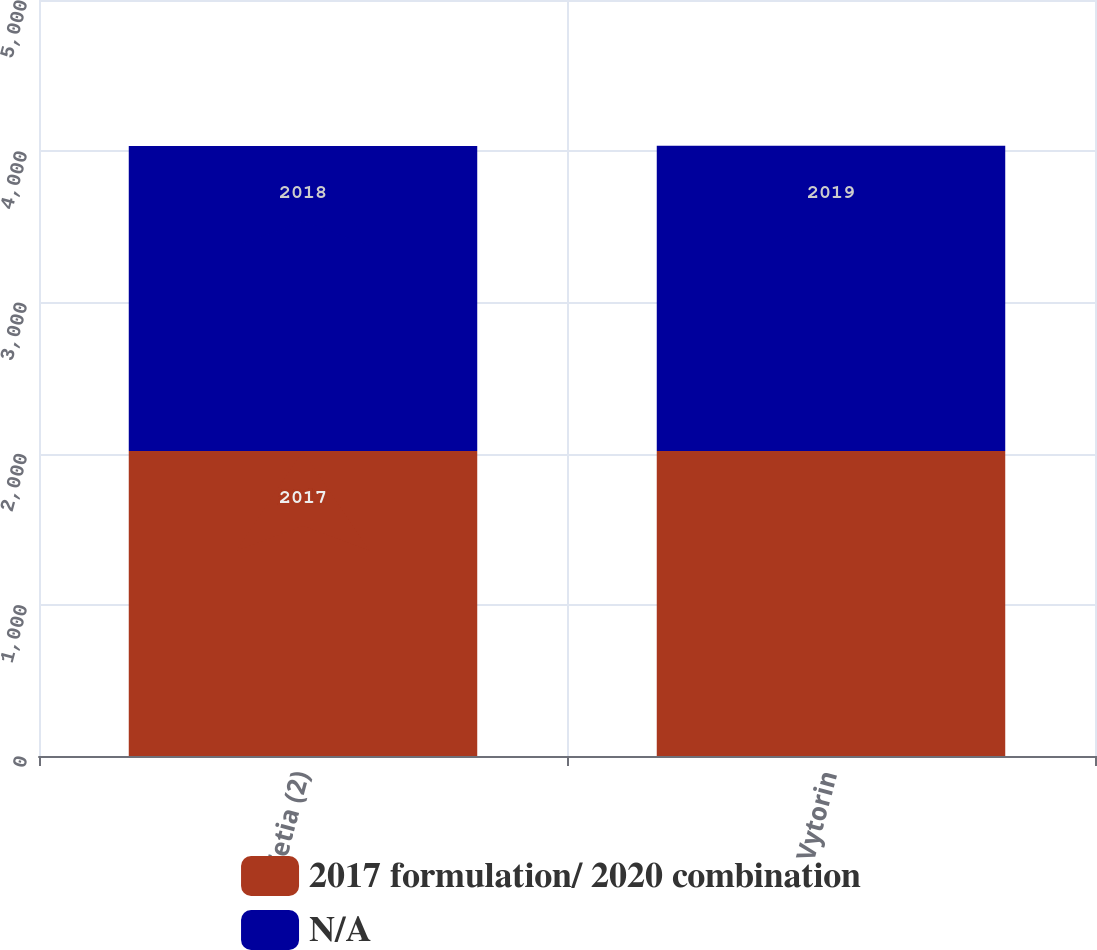Convert chart. <chart><loc_0><loc_0><loc_500><loc_500><stacked_bar_chart><ecel><fcel>Zetia (2)<fcel>Vytorin<nl><fcel>2017 formulation/ 2020 combination<fcel>2017<fcel>2017<nl><fcel>nan<fcel>2018<fcel>2019<nl></chart> 